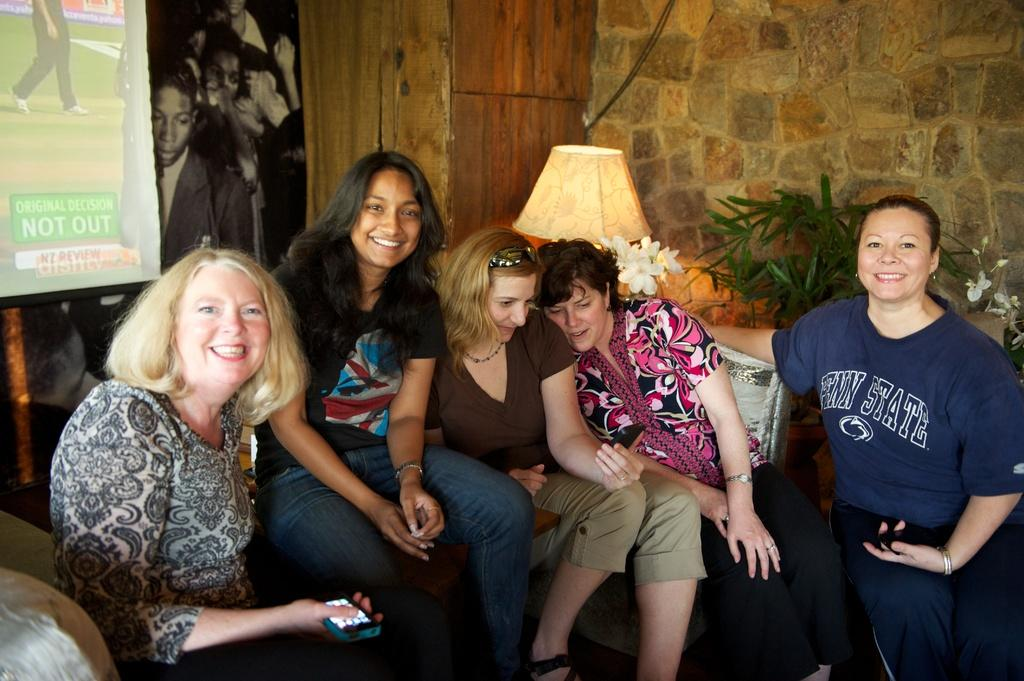How many women are present in the image? There are five women in the image. What are the women doing in the image? The women are sitting in the image. What expressions do the women have in the image? The women are smiling in the image. What can be seen in the background of the image? There is a wall, a lamp, leaves, flowers, and posters in the background of the image. What type of jam is being spread on the engine in the image? There is no jam or engine present in the image. How does the road affect the women's sitting position in the image? There is no road visible in the image, and therefore it does not affect the women's sitting position. 